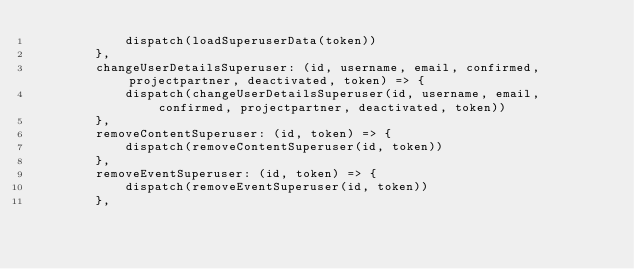Convert code to text. <code><loc_0><loc_0><loc_500><loc_500><_JavaScript_>            dispatch(loadSuperuserData(token))
        },
        changeUserDetailsSuperuser: (id, username, email, confirmed, projectpartner, deactivated, token) => {
            dispatch(changeUserDetailsSuperuser(id, username, email, confirmed, projectpartner, deactivated, token))
        },
        removeContentSuperuser: (id, token) => {
            dispatch(removeContentSuperuser(id, token))
        },
        removeEventSuperuser: (id, token) => {
            dispatch(removeEventSuperuser(id, token))
        },</code> 